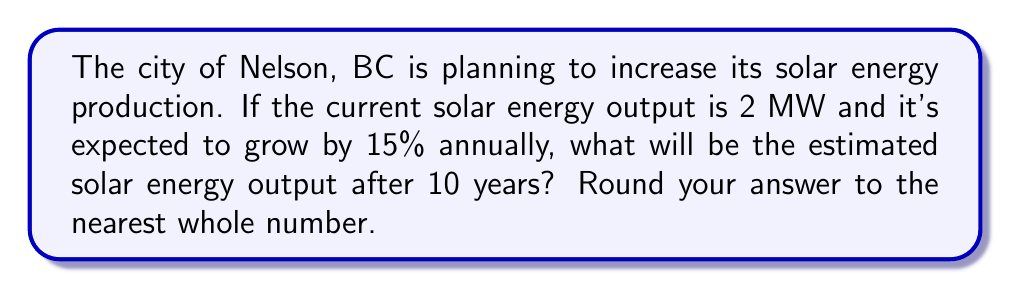Teach me how to tackle this problem. Let's approach this step-by-step using an exponential growth model:

1) The exponential growth formula is:
   $A = P(1 + r)^t$
   where:
   $A$ = Final amount
   $P$ = Initial principal balance
   $r$ = Annual growth rate (in decimal form)
   $t$ = Number of years

2) In this problem:
   $P = 2$ MW (initial output)
   $r = 0.15$ (15% converted to decimal)
   $t = 10$ years

3) Plugging these values into the formula:
   $A = 2(1 + 0.15)^{10}$

4) Simplify inside the parentheses:
   $A = 2(1.15)^{10}$

5) Calculate the exponent:
   $(1.15)^{10} \approx 4.0456$

6) Multiply by the initial amount:
   $A = 2 \times 4.0456 = 8.0912$ MW

7) Rounding to the nearest whole number:
   $A \approx 8$ MW
Answer: 8 MW 